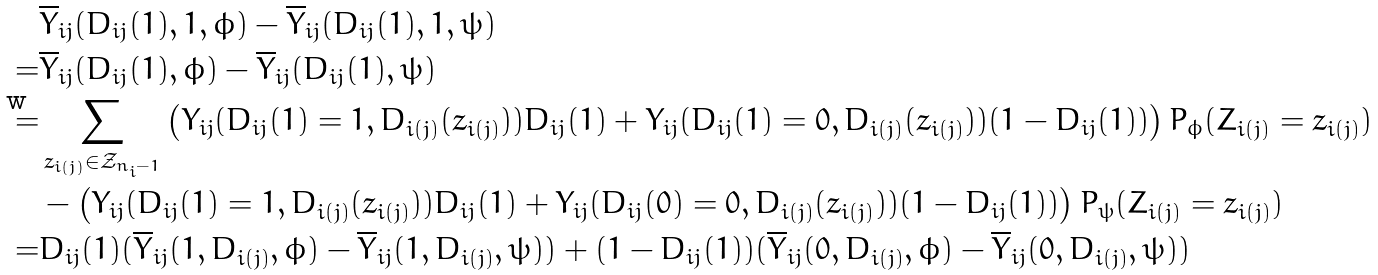Convert formula to latex. <formula><loc_0><loc_0><loc_500><loc_500>& \overline { Y } _ { i j } ( D _ { i j } ( 1 ) , 1 , \phi ) - \overline { Y } _ { i j } ( D _ { i j } ( 1 ) , 1 , \psi ) \\ = & \overline { Y } _ { i j } ( D _ { i j } ( 1 ) , \phi ) - \overline { Y } _ { i j } ( D _ { i j } ( 1 ) , \psi ) \\ = & \sum _ { z _ { i ( j ) } \in \mathcal { Z } _ { n _ { i } - 1 } } \left ( Y _ { i j } ( D _ { i j } ( 1 ) = 1 , D _ { i ( j ) } ( z _ { i ( j ) } ) ) D _ { i j } ( 1 ) + Y _ { i j } ( D _ { i j } ( 1 ) = 0 , D _ { i ( j ) } ( z _ { i ( j ) } ) ) ( 1 - D _ { i j } ( 1 ) ) \right ) P _ { \phi } ( Z _ { i ( j ) } = z _ { i ( j ) } ) \\ \quad & - \left ( Y _ { i j } ( D _ { i j } ( 1 ) = 1 , D _ { i ( j ) } ( z _ { i ( j ) } ) ) D _ { i j } ( 1 ) + Y _ { i j } ( D _ { i j } ( 0 ) = 0 , D _ { i ( j ) } ( z _ { i ( j ) } ) ) ( 1 - D _ { i j } ( 1 ) ) \right ) P _ { \psi } ( Z _ { i ( j ) } = z _ { i ( j ) } ) \\ = & D _ { i j } ( 1 ) ( \overline { Y } _ { i j } ( 1 , D _ { i ( j ) } , \phi ) - \overline { Y } _ { i j } ( 1 , D _ { i ( j ) } , \psi ) ) + ( 1 - D _ { i j } ( 1 ) ) ( \overline { Y } _ { i j } ( 0 , D _ { i ( j ) } , \phi ) - \overline { Y } _ { i j } ( 0 , D _ { i ( j ) } , \psi ) )</formula> 